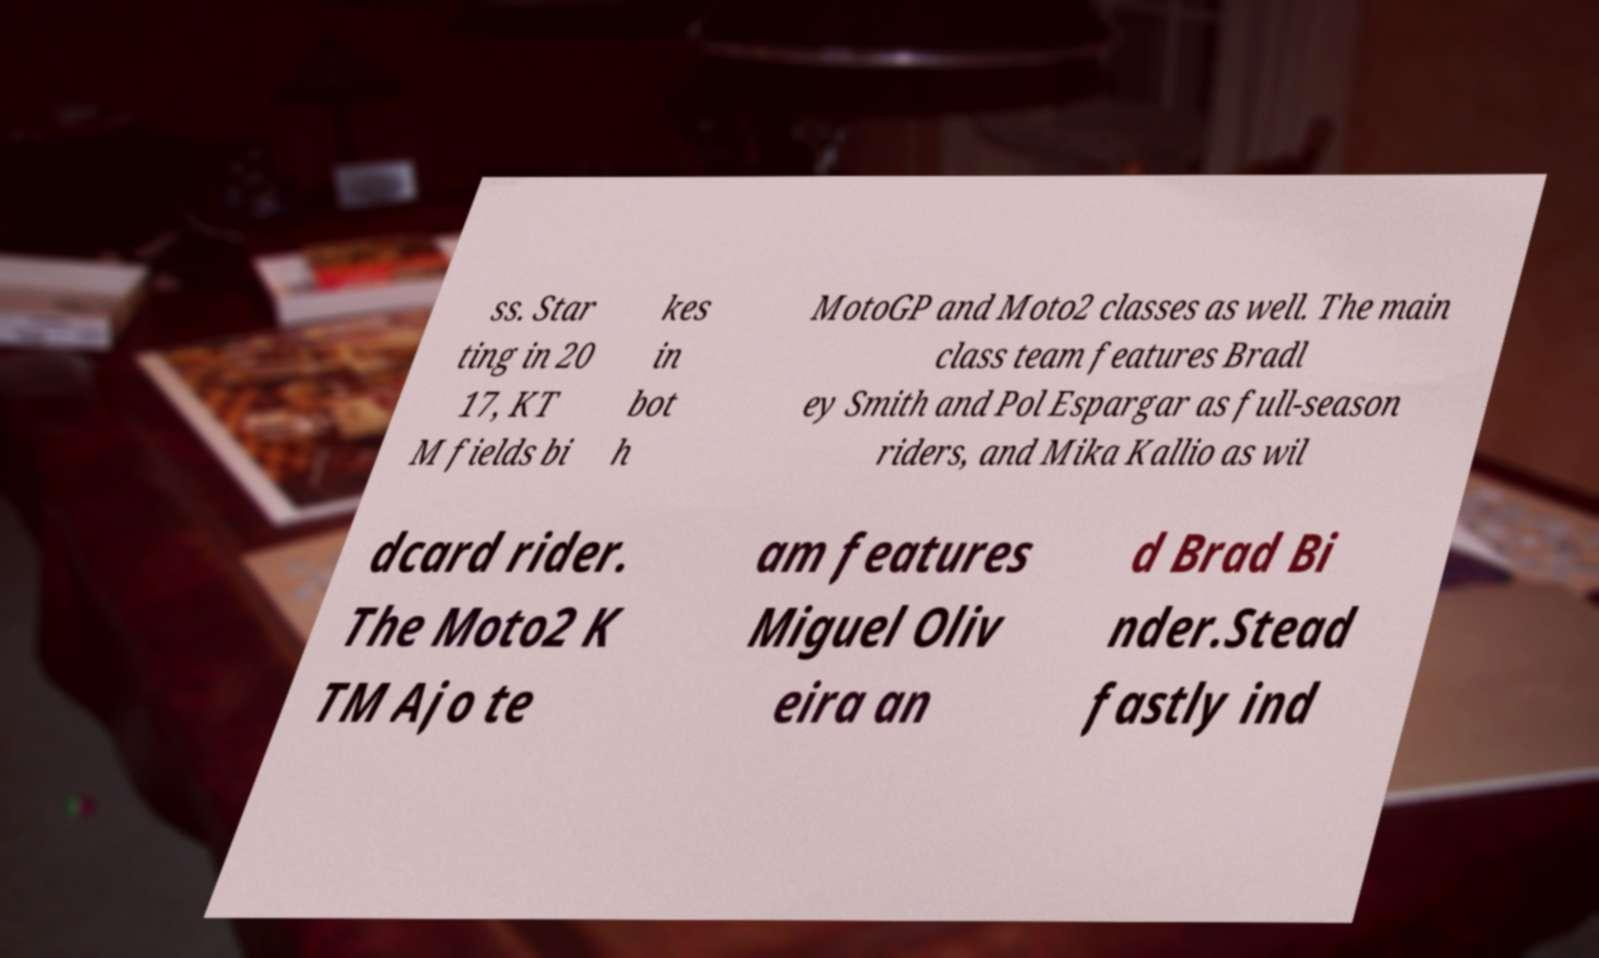Please identify and transcribe the text found in this image. ss. Star ting in 20 17, KT M fields bi kes in bot h MotoGP and Moto2 classes as well. The main class team features Bradl ey Smith and Pol Espargar as full-season riders, and Mika Kallio as wil dcard rider. The Moto2 K TM Ajo te am features Miguel Oliv eira an d Brad Bi nder.Stead fastly ind 